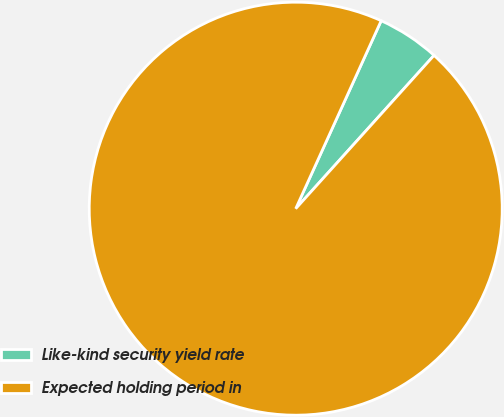Convert chart. <chart><loc_0><loc_0><loc_500><loc_500><pie_chart><fcel>Like-kind security yield rate<fcel>Expected holding period in<nl><fcel>4.89%<fcel>95.11%<nl></chart> 